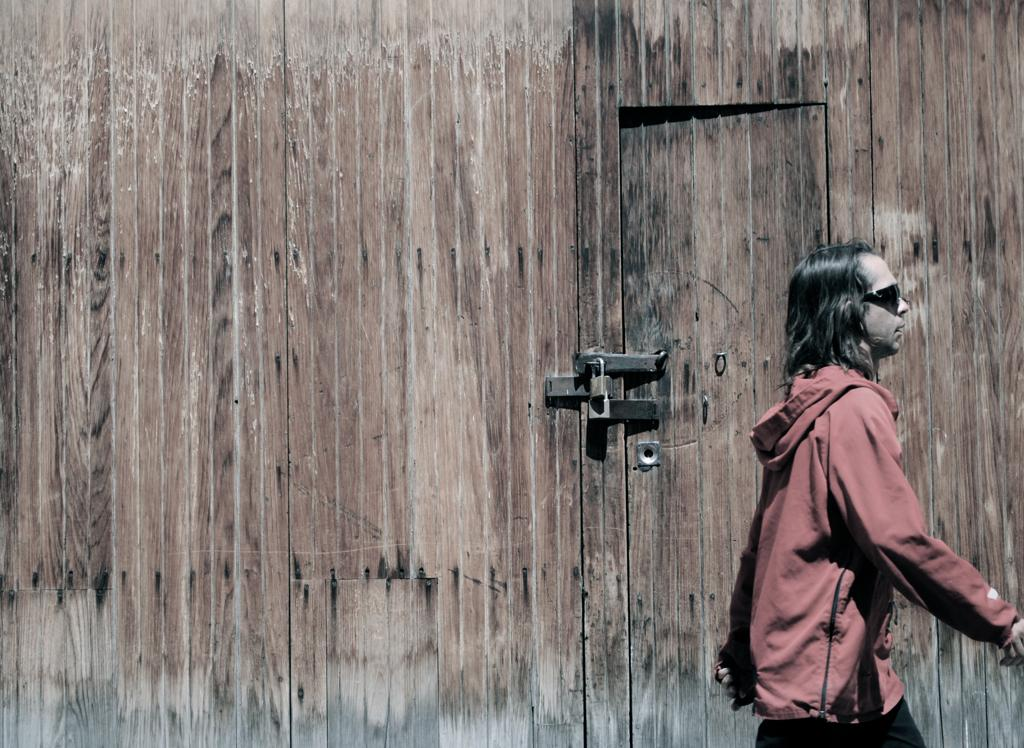Who is present in the image? There is a man in the image. Where is the man located in the image? The man is standing on the right side. What is the man wearing in the image? The man is wearing a red jacket and black shades. What can be seen in the background of the image? There is a door in the background of the image, and it has a lock on it. What type of lunchroom is visible in the image? There is no lunchroom present in the image. What market is the man shopping at in the image? There is no market present in the image. 